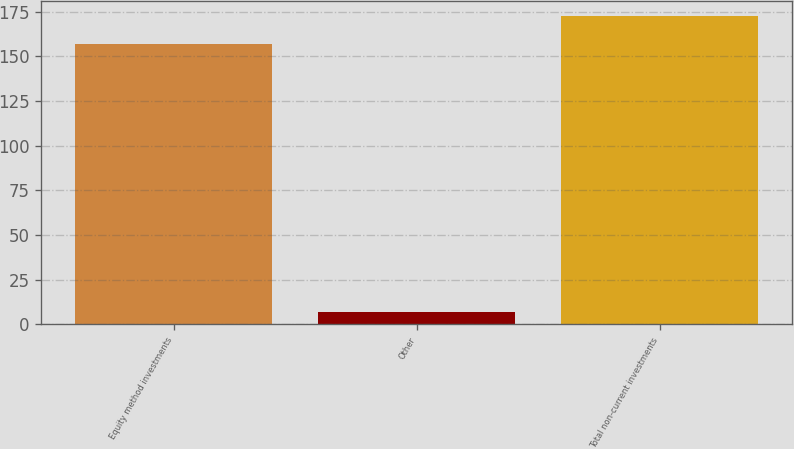<chart> <loc_0><loc_0><loc_500><loc_500><bar_chart><fcel>Equity method investments<fcel>Other<fcel>Total non-current investments<nl><fcel>156.9<fcel>7<fcel>172.64<nl></chart> 